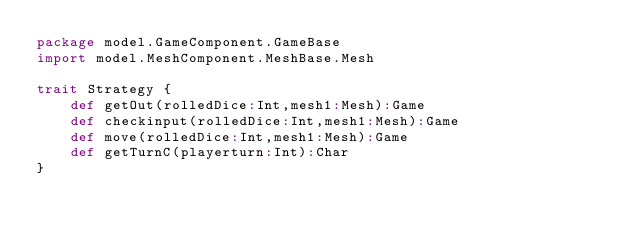<code> <loc_0><loc_0><loc_500><loc_500><_Scala_>package model.GameComponent.GameBase
import model.MeshComponent.MeshBase.Mesh

trait Strategy {
    def getOut(rolledDice:Int,mesh1:Mesh):Game
    def checkinput(rolledDice:Int,mesh1:Mesh):Game
    def move(rolledDice:Int,mesh1:Mesh):Game
    def getTurnC(playerturn:Int):Char
}
</code> 